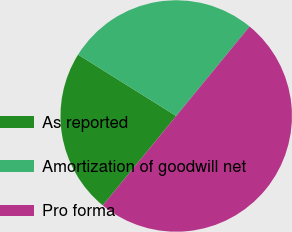<chart> <loc_0><loc_0><loc_500><loc_500><pie_chart><fcel>As reported<fcel>Amortization of goodwill net<fcel>Pro forma<nl><fcel>22.96%<fcel>27.04%<fcel>50.0%<nl></chart> 